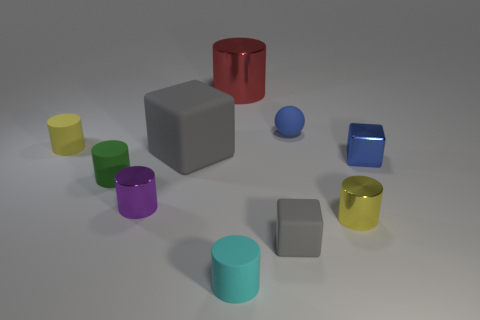Are there more small cyan cylinders than red blocks?
Ensure brevity in your answer.  Yes. How many things are either yellow cylinders that are behind the small shiny cube or metal things?
Provide a succinct answer. 5. Is the material of the tiny ball the same as the big cylinder?
Keep it short and to the point. No. There is another yellow thing that is the same shape as the yellow shiny thing; what is its size?
Make the answer very short. Small. There is a tiny yellow thing that is behind the purple metallic object; is its shape the same as the tiny metal thing that is left of the small blue sphere?
Provide a succinct answer. Yes. There is a red cylinder; is it the same size as the gray matte thing that is behind the yellow metallic cylinder?
Your response must be concise. Yes. How many other objects are the same material as the big red cylinder?
Your response must be concise. 3. Is there any other thing that has the same shape as the blue rubber object?
Provide a short and direct response. No. There is a tiny rubber ball on the left side of the tiny yellow cylinder in front of the gray rubber cube that is left of the large red thing; what color is it?
Your answer should be very brief. Blue. The shiny thing that is both left of the small matte ball and right of the purple cylinder has what shape?
Your response must be concise. Cylinder. 